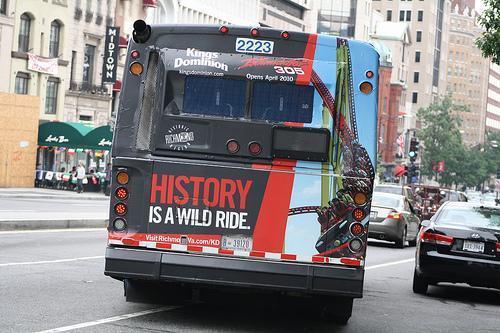How many buses are in the photo?
Give a very brief answer. 1. 